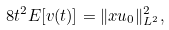Convert formula to latex. <formula><loc_0><loc_0><loc_500><loc_500>8 t ^ { 2 } E [ v ( t ) ] = \| x u _ { 0 } \| _ { L ^ { 2 } } ^ { 2 } ,</formula> 